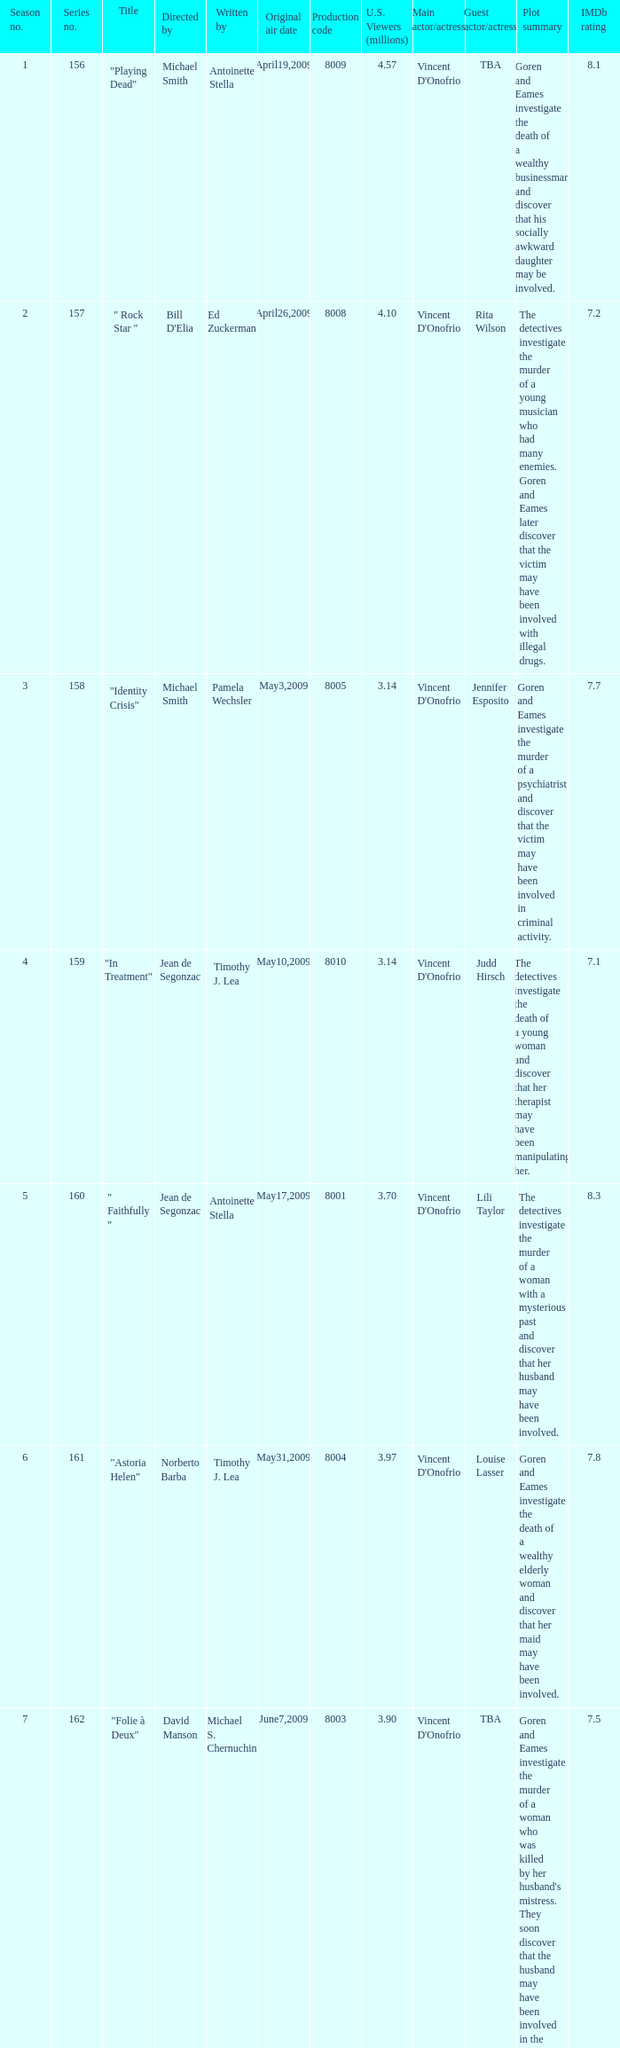Who are the writer of the series episode number 170? Walon Green. 